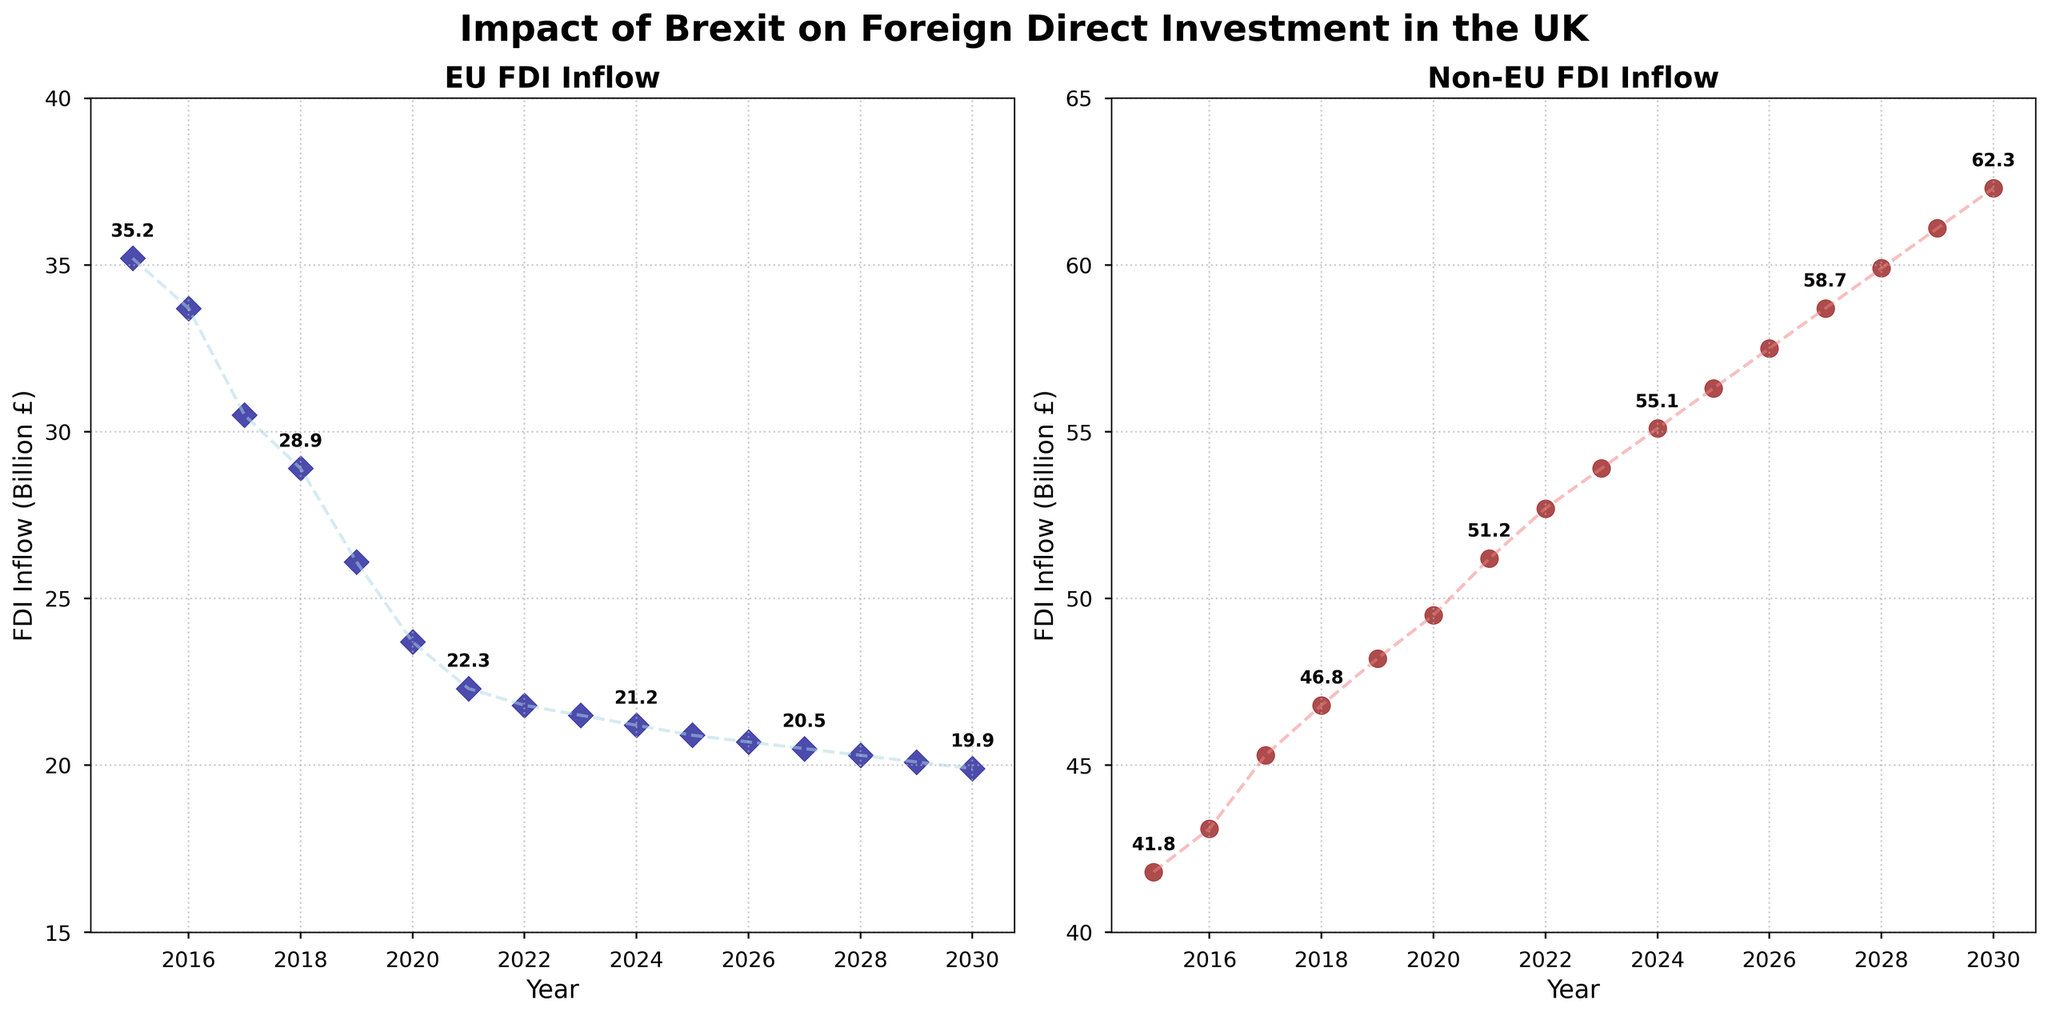What is the trend of EU FDI inflow from 2015 to 2030? To determine the trend, we observe the plotted points and lines. The points show a steady decline in EU FDI inflow over the years, and the line connecting the points also trends downward. This indicates a decreasing trend.
Answer: Decreasing How does the non-EU FDI inflow in 2020 compare to 2016? Look at the values marked for the years 2020 and 2016 in the non-EU FDI plot. The FDI inflow in 2020 is higher than in 2016 (49.5 billion £ vs. 43.1 billion £).
Answer: 2020 is higher Which year sees the highest EU FDI inflow? By scanning the EU FDI 'scatter' plot, the highest value appears at the beginning of the timeline in 2015. This point is marked at 35.2 billion £.
Answer: 2015 In what year does the EU FDI inflow first drop below 25 billion £? Look carefully at the EU FDI inflow plot. The year where the first time the inflow drops below 25 billion £ is around 2020.
Answer: 2020 What is the combined FDI inflow from EU and non-EU countries in 2025? First, find the values for EU and non-EU FDI inflow in 2025 (EU: 20.9; Non-EU: 56.3). Then, sum them up: 20.9 + 56.3 = 77.2 billion £.
Answer: 77.2 billion £ What has a steeper decline: EU FDI inflow or a steeper increase: non-EU FDI inflow from 2015 to 2030? Compare the slopes of the trends by observing the angle of the lines connecting the points. The EU FDI shows a sharp decline while non-EU FDI has a significant but more gradual increase. The EU FDI has a steeper decline.
Answer: EU FDI inflow declines steeper How often is the exact FDI inflow value annotated in the EU plot? Annotated values are marked every third year in the EU plot. This can be seen because not every point has an annotation, but roughly every third one does.
Answer: Every third year By how much did the non-EU FDI inflow increase from 2015 to 2030? The non-EU FDI inflow in 2015 is 41.8 billion £ and in 2030 is 62.3 billion £. Calculate the difference: 62.3 - 41.8 = 20.5 billion £.
Answer: 20.5 billion £ At what years are the EU FDI inflows specifically annotated in the plot? By looking at the annotations on the plot, the years specifically annotated for EU FDI inflow are every third year: 2015, 2018, 2021, 2024, 2027, and 2030.
Answer: 2015, 2018, 2021, 2024, 2027, 2030 Which inflow has a higher value in 2027: EU or non-EU? Refer to the respective plots for the values in 2027. The EU FDI inflow is 20.5 billion £, while the non-EU FDI inflow is 58.7 billion £. Non-EU has a higher value.
Answer: Non-EU 